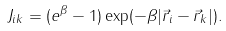<formula> <loc_0><loc_0><loc_500><loc_500>J _ { i k } = ( e ^ { \beta } - 1 ) \exp ( - \beta | \vec { r } _ { i } - \vec { r } _ { k } | ) .</formula> 